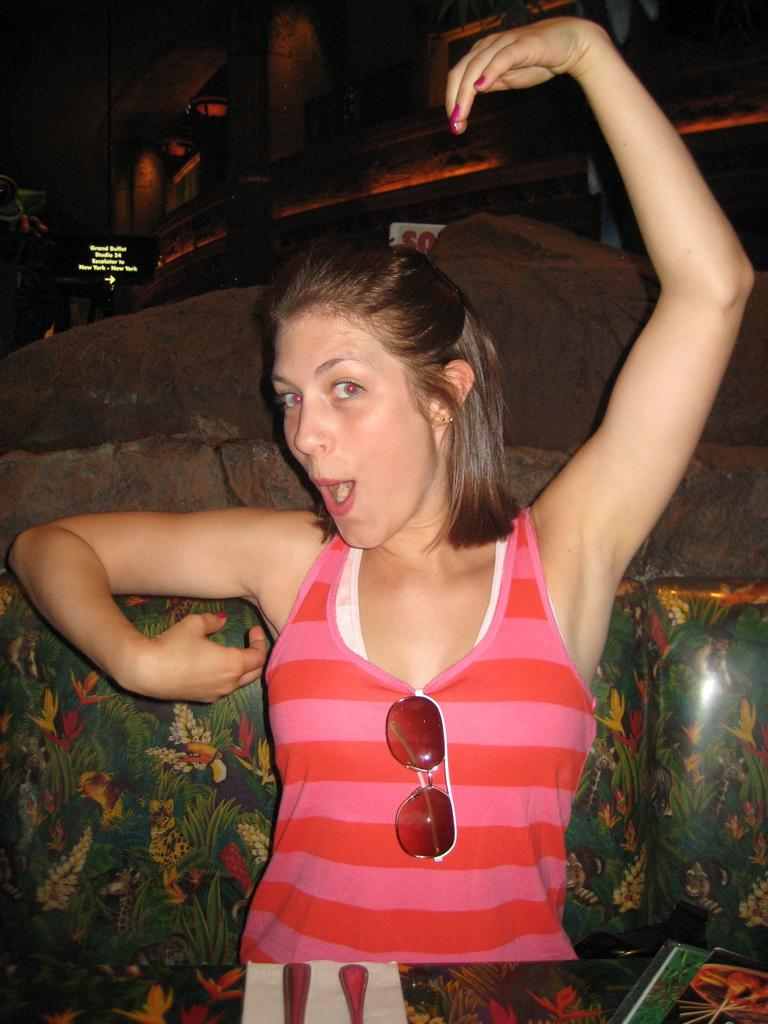Who is present in the image? There is a woman in the image. What type of instrument is the woman playing in the image? There is no instrument present in the image; it only features a woman. 